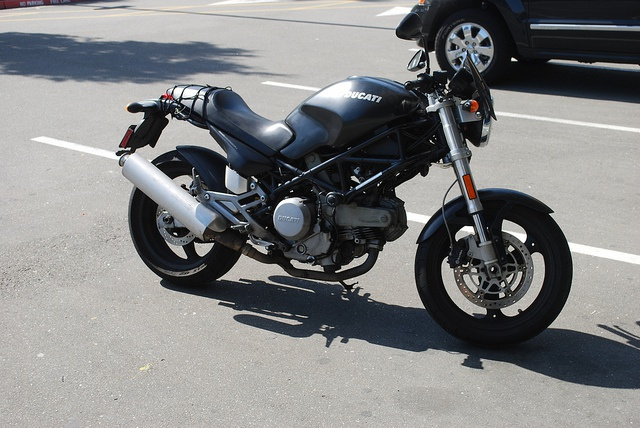Describe the objects in this image and their specific colors. I can see motorcycle in black, darkgray, gray, and lightgray tones and car in black, darkgray, gray, and navy tones in this image. 